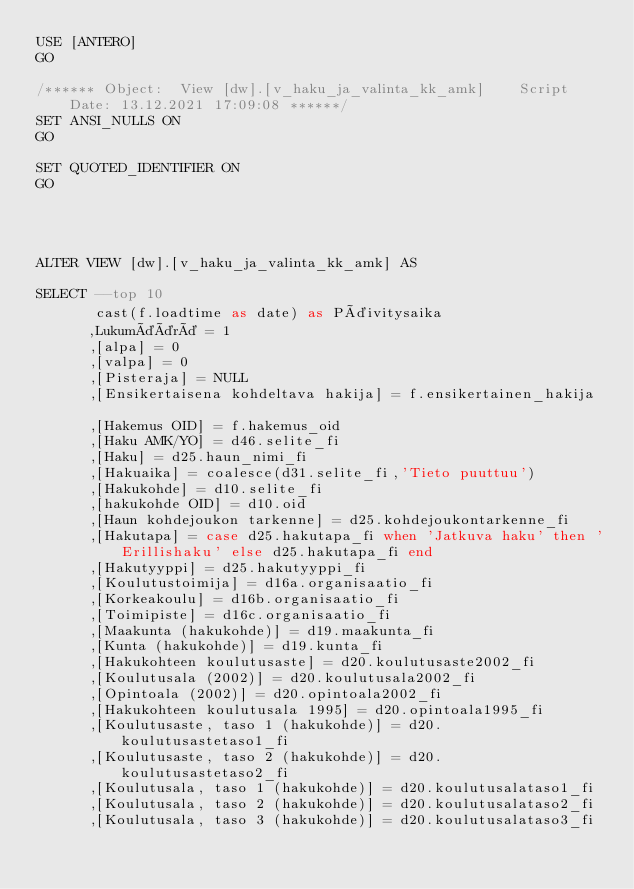<code> <loc_0><loc_0><loc_500><loc_500><_SQL_>USE [ANTERO]
GO

/****** Object:  View [dw].[v_haku_ja_valinta_kk_amk]    Script Date: 13.12.2021 17:09:08 ******/
SET ANSI_NULLS ON
GO

SET QUOTED_IDENTIFIER ON
GO




ALTER VIEW [dw].[v_haku_ja_valinta_kk_amk] AS

SELECT --top 10
	   cast(f.loadtime as date) as Päivitysaika
	  ,Lukumäärä = 1
	  ,[alpa] = 0
      ,[valpa] = 0
	  ,[Pisteraja] = NULL
	  ,[Ensikertaisena kohdeltava hakija] = f.ensikertainen_hakija	
	  ,[Hakemus OID] = f.hakemus_oid
	  ,[Haku AMK/YO] = d46.selite_fi
	  ,[Haku] = d25.haun_nimi_fi
	  ,[Hakuaika] = coalesce(d31.selite_fi,'Tieto puuttuu')
	  ,[Hakukohde] = d10.selite_fi
	  ,[hakukohde OID] = d10.oid
	  ,[Haun kohdejoukon tarkenne] = d25.kohdejoukontarkenne_fi
	  ,[Hakutapa] = case d25.hakutapa_fi when 'Jatkuva haku' then 'Erillishaku' else d25.hakutapa_fi end
	  ,[Hakutyyppi] = d25.hakutyyppi_fi
	  ,[Koulutustoimija] = d16a.organisaatio_fi
	  ,[Korkeakoulu] = d16b.organisaatio_fi
	  ,[Toimipiste] = d16c.organisaatio_fi
	  ,[Maakunta (hakukohde)] = d19.maakunta_fi
	  ,[Kunta (hakukohde)] = d19.kunta_fi
	  ,[Hakukohteen koulutusaste] = d20.koulutusaste2002_fi
	  ,[Koulutusala (2002)] = d20.koulutusala2002_fi
	  ,[Opintoala (2002)] = d20.opintoala2002_fi
	  ,[Hakukohteen koulutusala 1995] = d20.opintoala1995_fi
	  ,[Koulutusaste, taso 1 (hakukohde)] = d20.koulutusastetaso1_fi
	  ,[Koulutusaste, taso 2 (hakukohde)] = d20.koulutusastetaso2_fi
	  ,[Koulutusala, taso 1 (hakukohde)] = d20.koulutusalataso1_fi
	  ,[Koulutusala, taso 2 (hakukohde)] = d20.koulutusalataso2_fi
	  ,[Koulutusala, taso 3 (hakukohde)] = d20.koulutusalataso3_fi</code> 